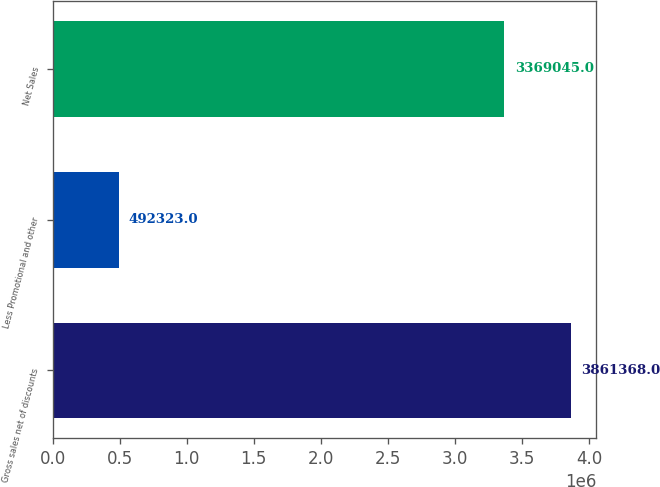Convert chart. <chart><loc_0><loc_0><loc_500><loc_500><bar_chart><fcel>Gross sales net of discounts<fcel>Less Promotional and other<fcel>Net Sales<nl><fcel>3.86137e+06<fcel>492323<fcel>3.36904e+06<nl></chart> 